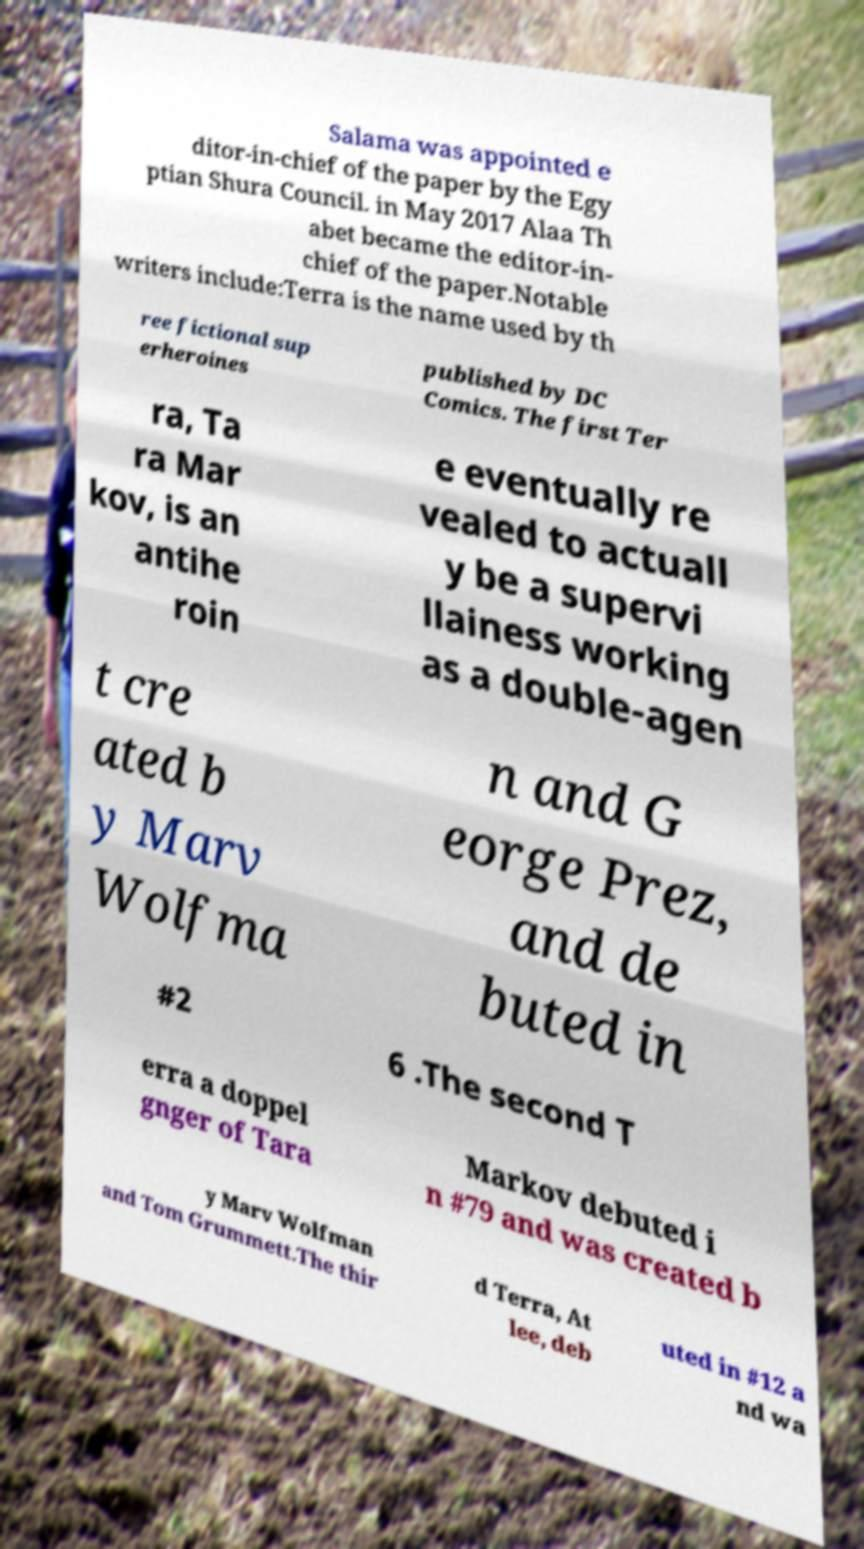There's text embedded in this image that I need extracted. Can you transcribe it verbatim? Salama was appointed e ditor-in-chief of the paper by the Egy ptian Shura Council. in May 2017 Alaa Th abet became the editor-in- chief of the paper.Notable writers include:Terra is the name used by th ree fictional sup erheroines published by DC Comics. The first Ter ra, Ta ra Mar kov, is an antihe roin e eventually re vealed to actuall y be a supervi llainess working as a double-agen t cre ated b y Marv Wolfma n and G eorge Prez, and de buted in #2 6 .The second T erra a doppel gnger of Tara Markov debuted i n #79 and was created b y Marv Wolfman and Tom Grummett.The thir d Terra, At lee, deb uted in #12 a nd wa 